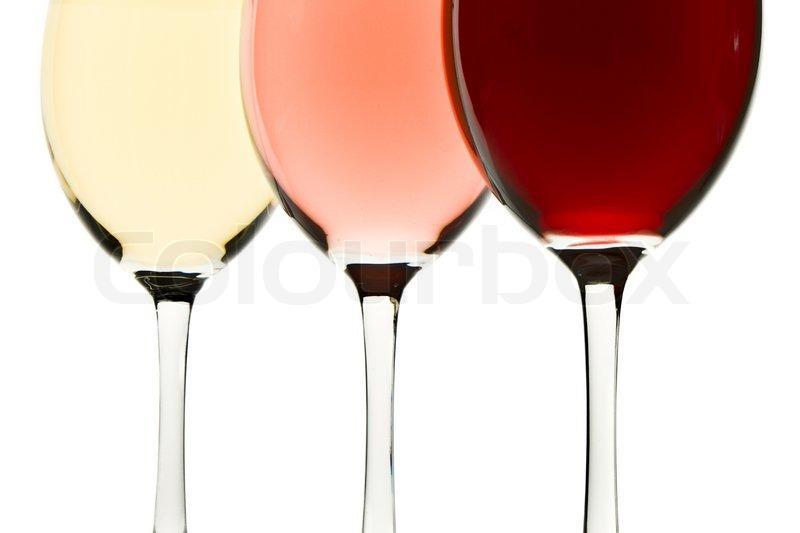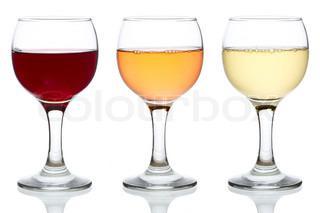The first image is the image on the left, the second image is the image on the right. Examine the images to the left and right. Is the description "An image includes a trio of stemmed glasses all containing red wine, with the middle glass in front of the other two." accurate? Answer yes or no. No. 